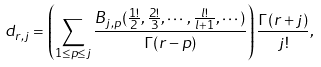Convert formula to latex. <formula><loc_0><loc_0><loc_500><loc_500>d _ { r , j } = \left ( \sum _ { 1 \leq p \leq j } \frac { B _ { j , p } ( \frac { 1 ! } { 2 } , \frac { 2 ! } { 3 } , \cdots , \frac { l ! } { l + 1 } , \cdots ) } { \Gamma ( r - p ) } \right ) \frac { \Gamma ( r + j ) } { j ! } ,</formula> 